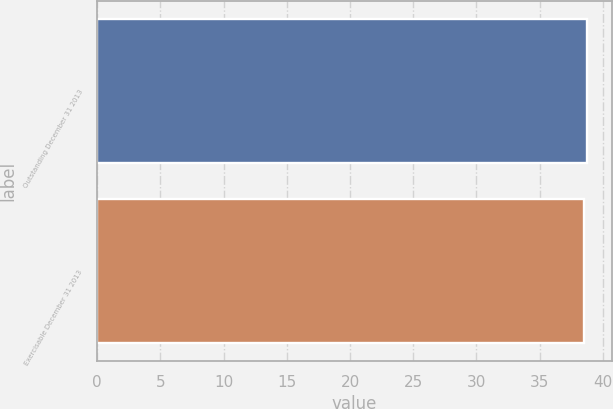<chart> <loc_0><loc_0><loc_500><loc_500><bar_chart><fcel>Outstanding December 31 2013<fcel>Exercisable December 31 2013<nl><fcel>38.75<fcel>38.48<nl></chart> 